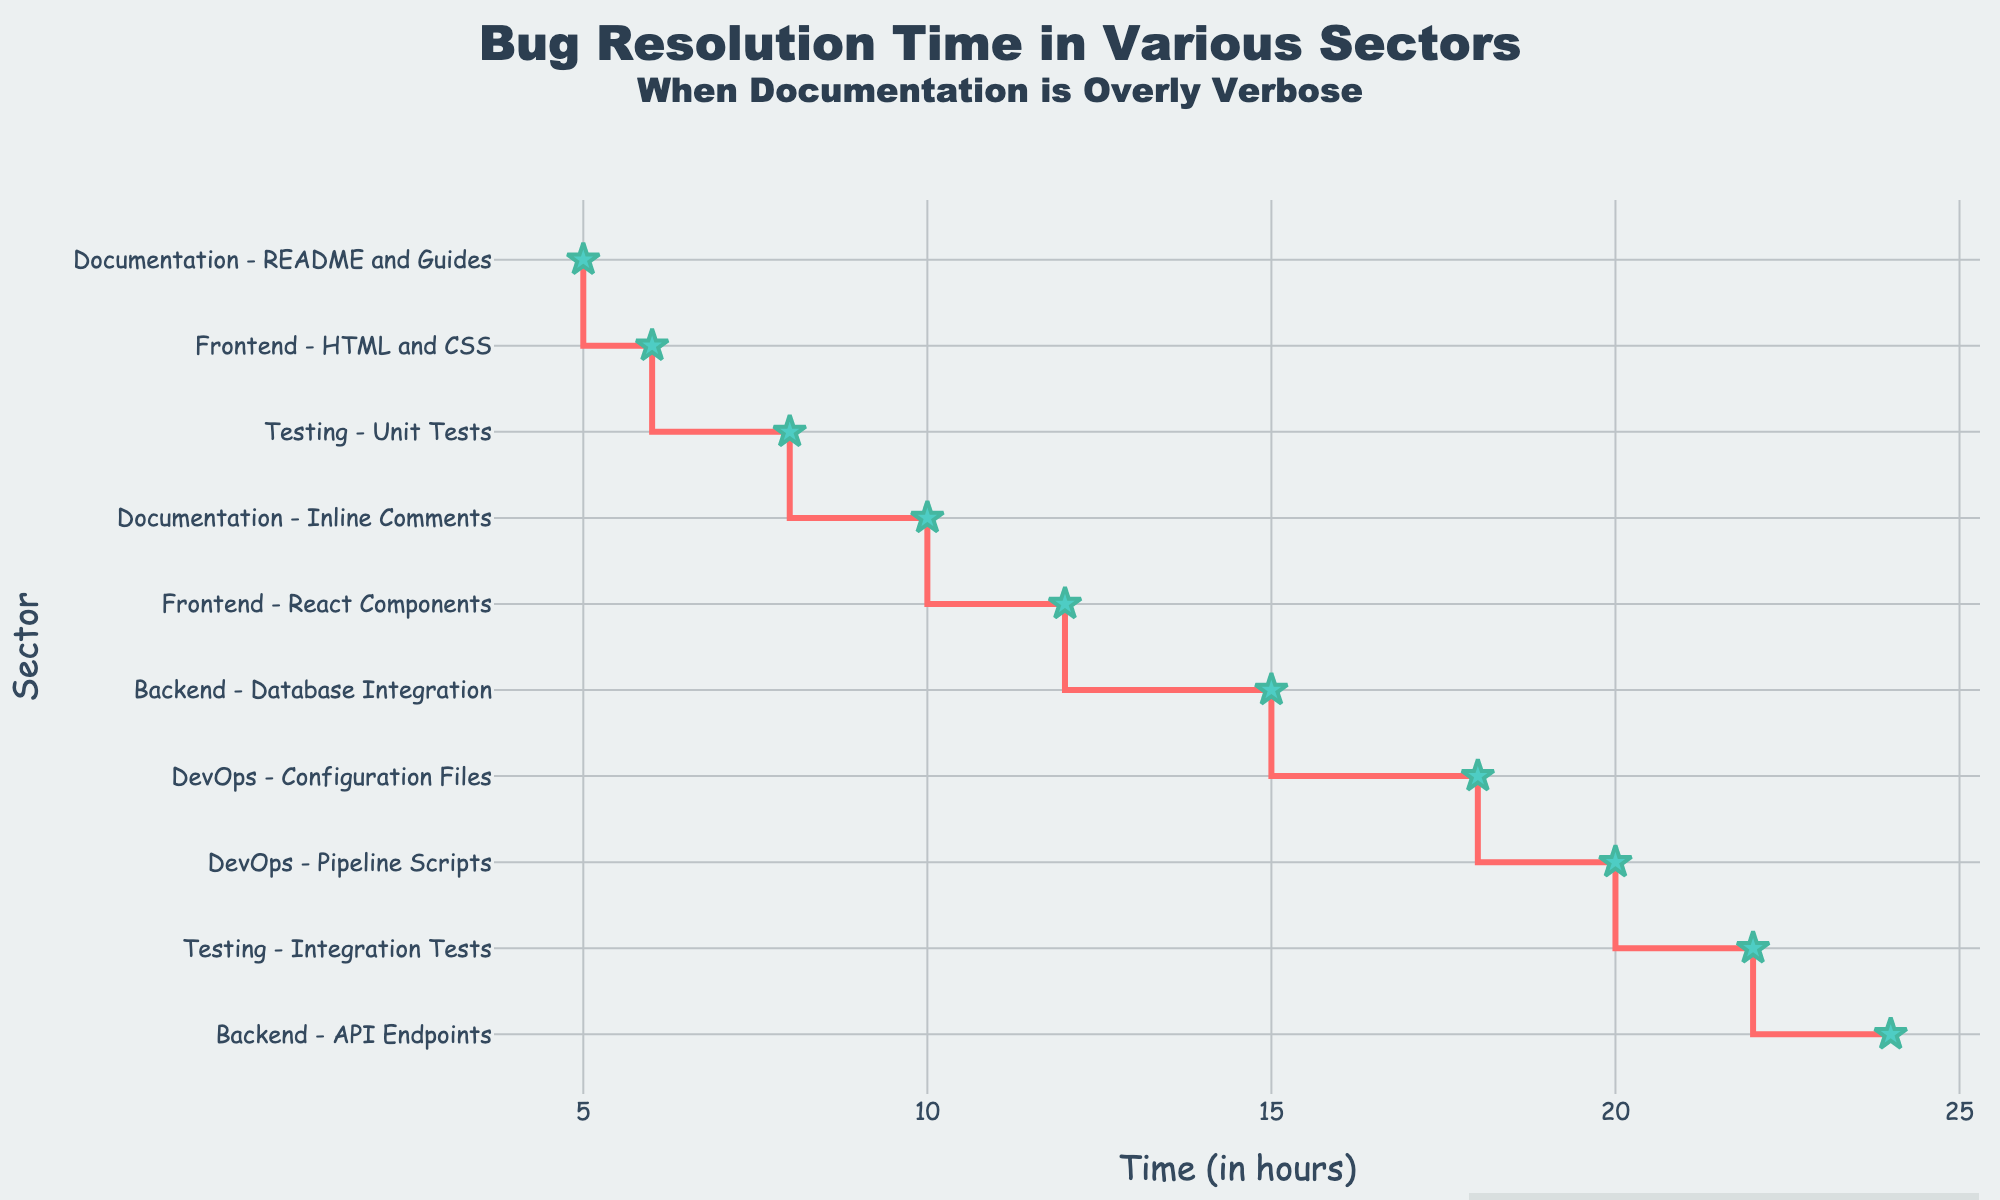How much time does it take to resolve bugs in Frontend - React Components? Identify the data point representing 'Frontend - React Components'. The associated time value is 12 hours.
Answer: 12 hours Which sector has the shortest bug resolution time? Identify the sector with the smallest value along the x-axis. 'Documentation - README and Guides' has the shortest time at 5 hours.
Answer: Documentation - README and Guides What is the total time taken for resolving bugs in both Backend sectors combined? Add the times for 'Backend - API Endpoints' (24 hours) and 'Backend - Database Integration' (15 hours). Total time is 24 + 15 = 39 hours.
Answer: 39 hours Is the bug resolution time in 'Documentation - Inline Comments' greater than 'Frontend - HTML and CSS'? Compare the times: 'Documentation - Inline Comments' (10 hours) and 'Frontend - HTML and CSS' (6 hours). Since 10 is greater than 6, the answer is yes.
Answer: Yes Which sector has a longer bug resolution time, 'DevOps - Pipeline Scripts' or 'Testing - Integration Tests'? Compare the times: 'DevOps - Pipeline Scripts' (20 hours) and 'Testing - Integration Tests' (22 hours). Since 22 is greater than 20, 'Testing - Integration Tests' has a longer time.
Answer: Testing - Integration Tests What's the average bug resolution time across all sectors? Sum all times and divide by the number of sectors. Total time: (12 + 6 + 24 + 15 + 20 + 18 + 8 + 22 + 5 + 10) = 140 hours. Average time is 140 / 10 = 14 hours.
Answer: 14 hours What is the difference in bug resolution times between 'DevOps - Configuration Files' and 'Testing - Unit Tests'? Subtract the time for 'Testing - Unit Tests' (8 hours) from 'DevOps - Configuration Files' (18 hours). The difference is 18 - 8 = 10 hours.
Answer: 10 hours What's the cumulative time spent on bug resolution in both 'Testing' sectors? Add the times for 'Testing - Unit Tests' (8 hours) and 'Testing - Integration Tests' (22 hours). Total time is 8 + 22 = 30 hours.
Answer: 30 hours What is the range of bug resolution times across all sectors? Find the difference between the maximum (24 hours for 'Backend - API Endpoints') and minimum (5 hours for 'Documentation - README and Guides') times. The range is 24 - 5 = 19 hours.
Answer: 19 hours Based on the plot, which sector has the most complex bug resolution process, considering time as an indicator? Identify the sector with the greatest value along the x-axis. 'Backend - API Endpoints' has the highest time at 24 hours, indicating it is the most complex.
Answer: Backend - API Endpoints 